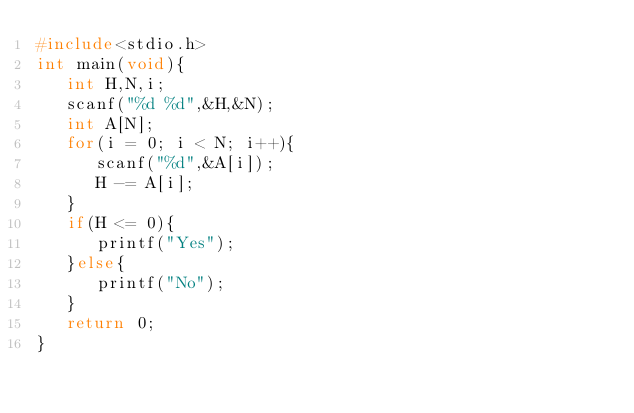Convert code to text. <code><loc_0><loc_0><loc_500><loc_500><_C_>#include<stdio.h>                                                 
int main(void){                                                   
   int H,N,i;                                                     
   scanf("%d %d",&H,&N);                                          
   int A[N];                                                      
   for(i = 0; i < N; i++){                                        
      scanf("%d",&A[i]);                                          
      H -= A[i];                                                  
   }                                                              
   if(H <= 0){                                                    
      printf("Yes");                                              
   }else{                                                         
      printf("No");                                               
   }                                                              
   return 0;                                                      
}</code> 